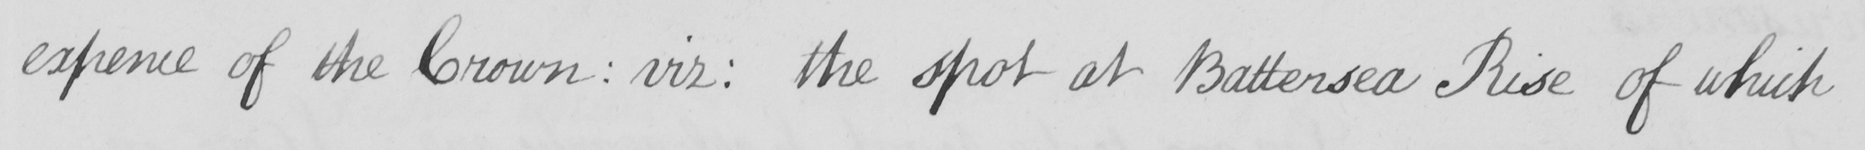Can you read and transcribe this handwriting? expense of the Crown :  viz :  the spot at Battersea Rise of which 